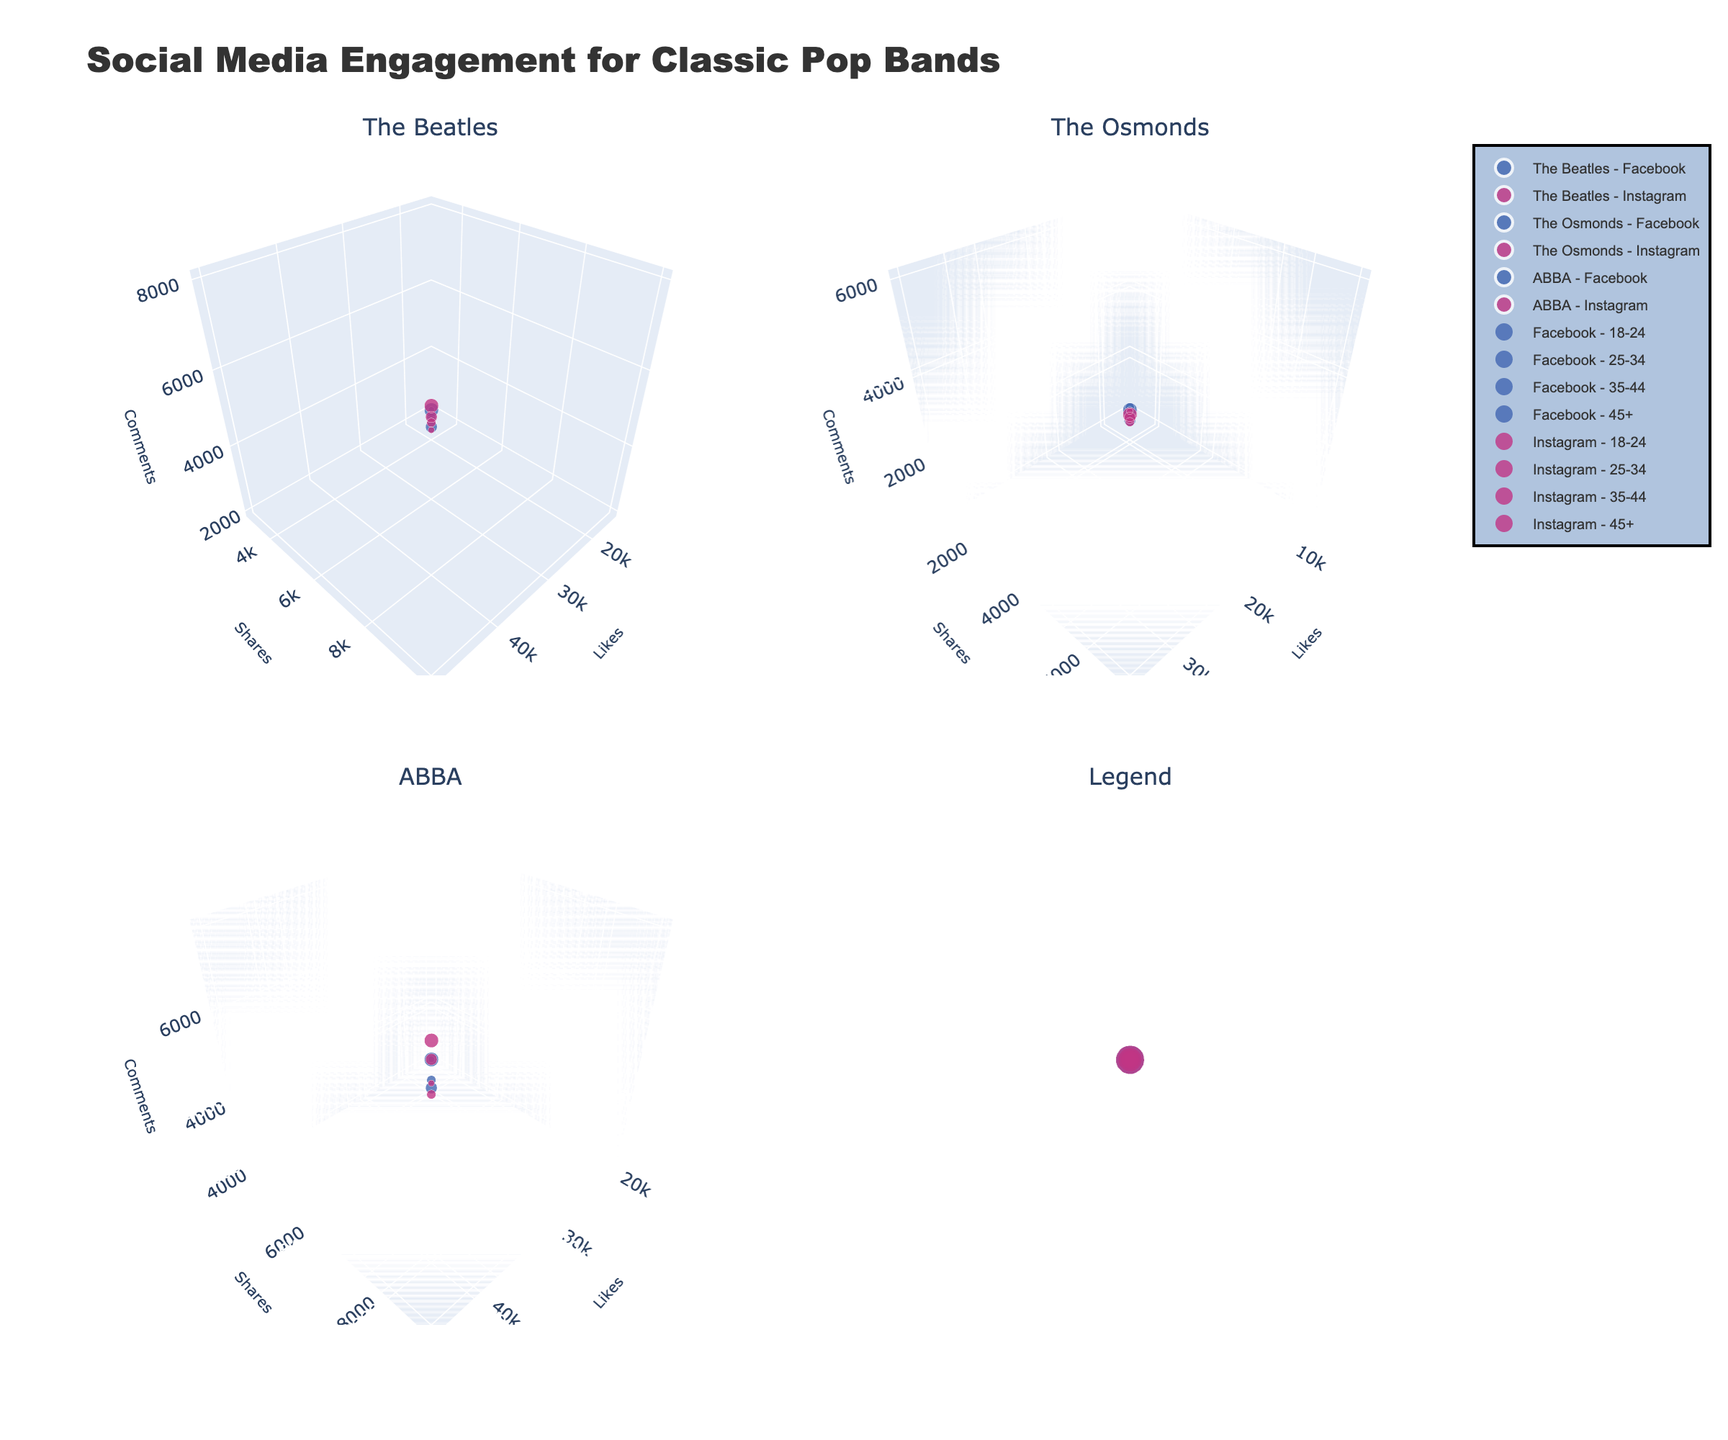What's the title of the figure? The title is typically placed at the top of the figure and provides an overview of what is being displayed. Here, the title is clearly mentioned in the provided code.
Answer: Social Media Engagement for Classic Pop Bands Which age group has the largest markers for Instagram in ABBA's subplot? Larger markers indicate the age group 45+. To find the largest markers, look for the biggest circles in the subplot for ABBA on Instagram. In this case, the size mapping signifies age group 45+.
Answer: 45+ How do the likes for The Beatles on Facebook compare between the 18-24 and 45+ age groups? Locate the subplot for The Beatles, then look for the markers corresponding to Facebook for both age groups. Compare the likes values along the x-axis. The 45+ age group has more likes.
Answer: 45+ has more likes Which platform, Facebook or Instagram, shows higher engagement for The Osmonds across all age groups? For comparison, look at the overall size and density of markers for both platforms in The Osmonds’ subplots. Instagram generally shows higher engagement across all age groups.
Answer: Instagram Which band has the most comments on Facebook for the 25-34 age group? Check the z-axis values in the subplots for each band on Facebook for the age group 25-34. ABBA has the highest comments here.
Answer: ABBA Compare the engagement (likes, shares, comments) for ABBA on Instagram and Facebook for the 18-24 age group. Assess the markers for both platforms for ABBA in the 18-24 age group. Compare the values on the x, y, and z axes for each platform. Instagram has higher likes and shares, while Facebook has fewer engagements in this group.
Answer: Instagram has higher Between The Beatles and The Osmonds, which band has more likes on Instagram for the 35-44 age group? Identify Instagram markers for both bands in the 35-44 age group, look at the x-axis (likes) in those plots, and compare. The Beatles have fewer likes than The Osmonds in this age group.
Answer: The Osmonds Which age group has the smallest marker size on Facebook for ABBA? Marker sizes correlate with age groups; the smallest marker size is for the 18-24 age group. Locate the smallest circles in ABBA’s subplot on Facebook.
Answer: 18-24 What is the trend of likes across different age groups for The Beatles on Instagram? Look at The Beatles’ Instagram subplot and observe the x-axis values for marker sizes of different age groups. Likes decrease as age increases from 18-24 to 45+.
Answer: Decreasing trend Compare the number of shares between The Osmonds and ABBA on Facebook for the 45+ age group. Look at the y-axis values for the 45+ age group markers in the subplots for The Osmonds and ABBA on Facebook. The Osmonds have fewer shares compared to ABBA.
Answer: ABBA has more shares 